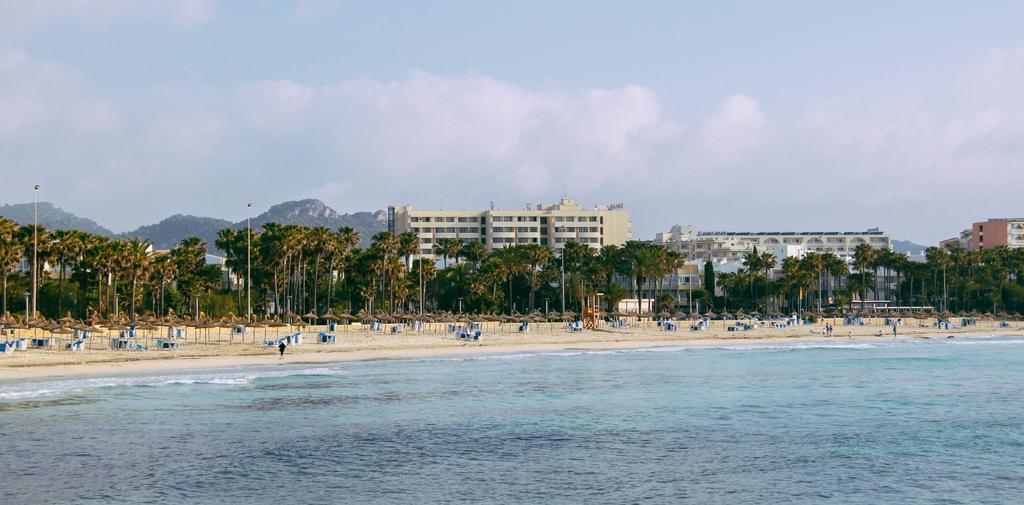Describe this image in one or two sentences. In this image we can see some buildings, poles, trees, mountains, windows, lights and some other objects on the ground, in the background we can see the sky with clouds. 